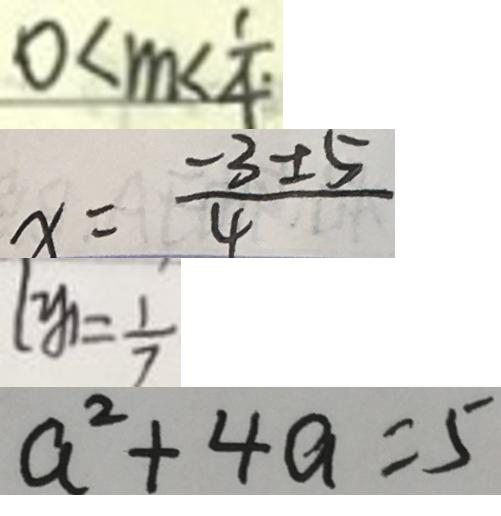Convert formula to latex. <formula><loc_0><loc_0><loc_500><loc_500>0 < m < \frac { 1 } { 4 \cdot } 
 x = \frac { - 3 \pm 5 } { 4 } 
 y _ { 1 } = \frac { 1 } { 7 } 
 a ^ { 2 } + 4 a = 5</formula> 